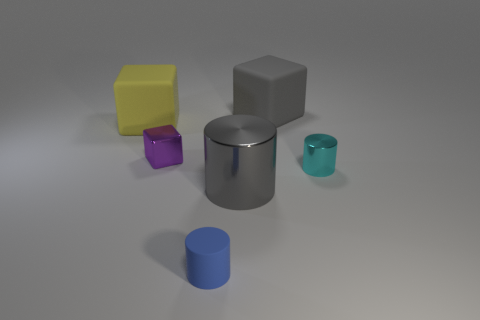Add 1 tiny blue balls. How many objects exist? 7 Subtract all purple metallic cubes. How many cubes are left? 2 Subtract all big gray metal things. Subtract all small cylinders. How many objects are left? 3 Add 4 purple objects. How many purple objects are left? 5 Add 6 cyan metallic cylinders. How many cyan metallic cylinders exist? 7 Subtract all gray blocks. How many blocks are left? 2 Subtract 1 gray blocks. How many objects are left? 5 Subtract 2 cylinders. How many cylinders are left? 1 Subtract all green cylinders. Subtract all brown spheres. How many cylinders are left? 3 